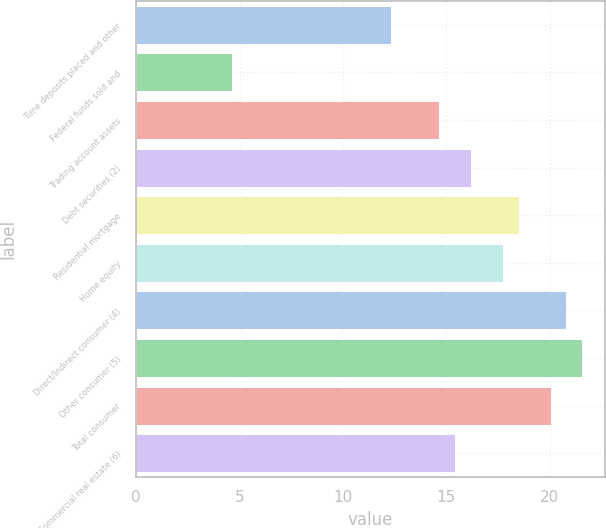<chart> <loc_0><loc_0><loc_500><loc_500><bar_chart><fcel>Time deposits placed and other<fcel>Federal funds sold and<fcel>Trading account assets<fcel>Debt securities (2)<fcel>Residential mortgage<fcel>Home equity<fcel>Direct/Indirect consumer (4)<fcel>Other consumer (5)<fcel>Total consumer<fcel>Commercial real estate (6)<nl><fcel>12.34<fcel>4.64<fcel>14.65<fcel>16.19<fcel>18.5<fcel>17.73<fcel>20.81<fcel>21.58<fcel>20.04<fcel>15.42<nl></chart> 